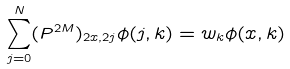Convert formula to latex. <formula><loc_0><loc_0><loc_500><loc_500>\sum _ { j = 0 } ^ { N } ( P ^ { 2 M } ) _ { 2 x , 2 j } \phi ( j , k ) = w _ { k } \phi ( x , k )</formula> 